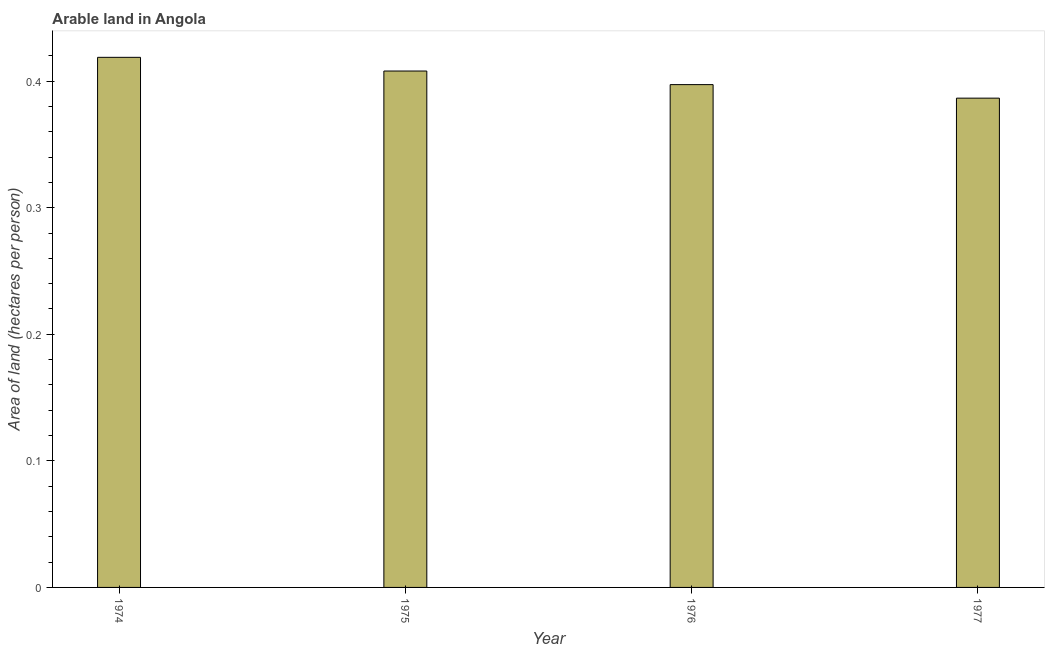What is the title of the graph?
Your answer should be compact. Arable land in Angola. What is the label or title of the Y-axis?
Offer a terse response. Area of land (hectares per person). What is the area of arable land in 1974?
Your answer should be very brief. 0.42. Across all years, what is the maximum area of arable land?
Provide a succinct answer. 0.42. Across all years, what is the minimum area of arable land?
Ensure brevity in your answer.  0.39. In which year was the area of arable land maximum?
Ensure brevity in your answer.  1974. In which year was the area of arable land minimum?
Your response must be concise. 1977. What is the sum of the area of arable land?
Ensure brevity in your answer.  1.61. What is the difference between the area of arable land in 1975 and 1977?
Your answer should be very brief. 0.02. What is the average area of arable land per year?
Your answer should be compact. 0.4. What is the median area of arable land?
Your response must be concise. 0.4. Do a majority of the years between 1977 and 1976 (inclusive) have area of arable land greater than 0.2 hectares per person?
Offer a very short reply. No. What is the ratio of the area of arable land in 1976 to that in 1977?
Offer a very short reply. 1.03. What is the difference between the highest and the second highest area of arable land?
Provide a succinct answer. 0.01. Is the sum of the area of arable land in 1974 and 1976 greater than the maximum area of arable land across all years?
Give a very brief answer. Yes. What is the difference between the highest and the lowest area of arable land?
Provide a succinct answer. 0.03. Are all the bars in the graph horizontal?
Ensure brevity in your answer.  No. Are the values on the major ticks of Y-axis written in scientific E-notation?
Provide a succinct answer. No. What is the Area of land (hectares per person) of 1974?
Make the answer very short. 0.42. What is the Area of land (hectares per person) in 1975?
Provide a short and direct response. 0.41. What is the Area of land (hectares per person) in 1976?
Offer a terse response. 0.4. What is the Area of land (hectares per person) in 1977?
Provide a short and direct response. 0.39. What is the difference between the Area of land (hectares per person) in 1974 and 1975?
Ensure brevity in your answer.  0.01. What is the difference between the Area of land (hectares per person) in 1974 and 1976?
Provide a short and direct response. 0.02. What is the difference between the Area of land (hectares per person) in 1974 and 1977?
Make the answer very short. 0.03. What is the difference between the Area of land (hectares per person) in 1975 and 1976?
Offer a very short reply. 0.01. What is the difference between the Area of land (hectares per person) in 1975 and 1977?
Make the answer very short. 0.02. What is the difference between the Area of land (hectares per person) in 1976 and 1977?
Give a very brief answer. 0.01. What is the ratio of the Area of land (hectares per person) in 1974 to that in 1976?
Make the answer very short. 1.05. What is the ratio of the Area of land (hectares per person) in 1974 to that in 1977?
Keep it short and to the point. 1.08. What is the ratio of the Area of land (hectares per person) in 1975 to that in 1976?
Give a very brief answer. 1.03. What is the ratio of the Area of land (hectares per person) in 1975 to that in 1977?
Your answer should be compact. 1.05. What is the ratio of the Area of land (hectares per person) in 1976 to that in 1977?
Provide a short and direct response. 1.03. 